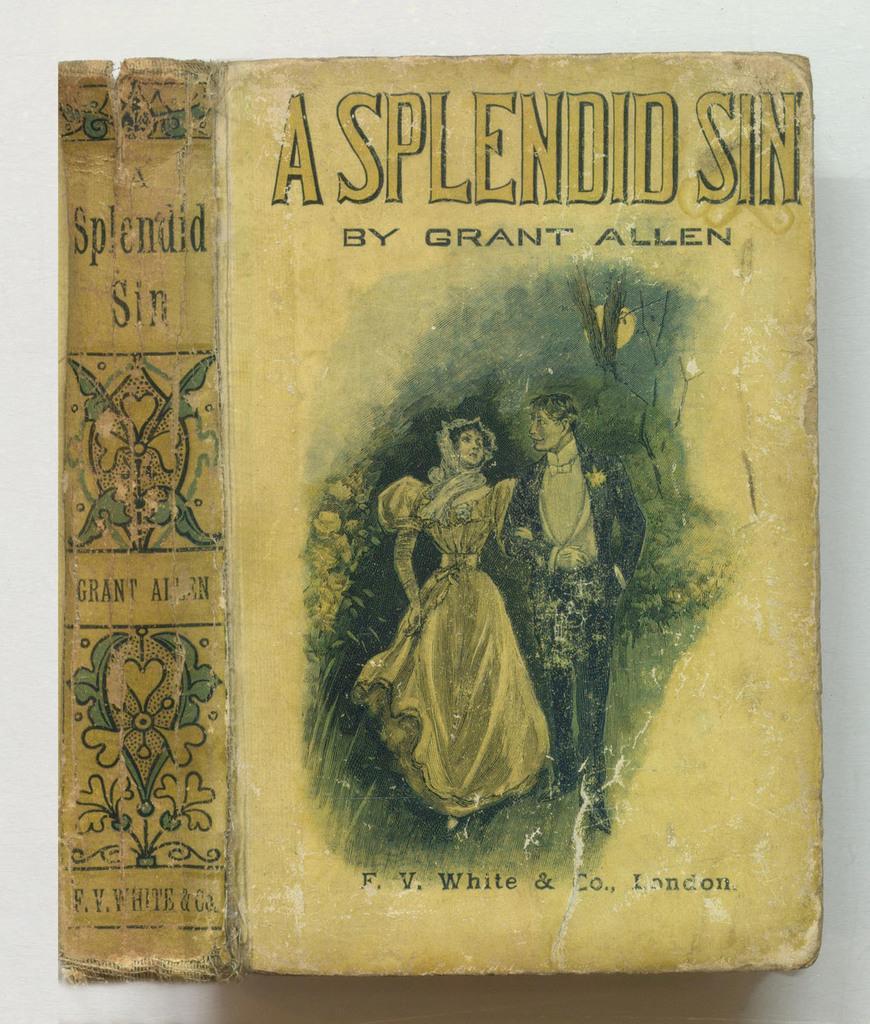<image>
Render a clear and concise summary of the photo. A book by Grant Allen has a couple on the front. 